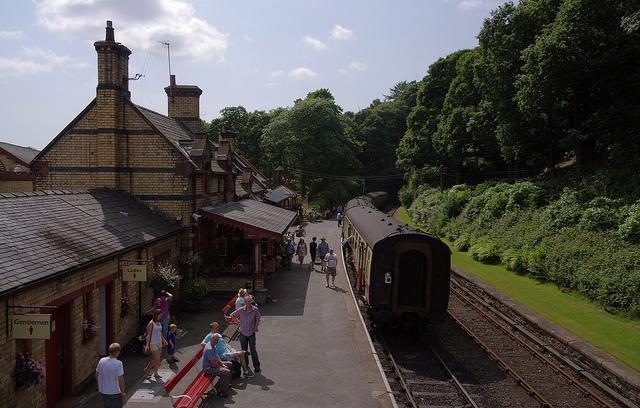In what direction will the train go next with respect to the person taking this person?
Select the correct answer and articulate reasoning with the following format: 'Answer: answer
Rationale: rationale.'
Options: South, north, south, east. Answer: north.
Rationale: Camera is behind train so train is pointed north of the person taking the photo 